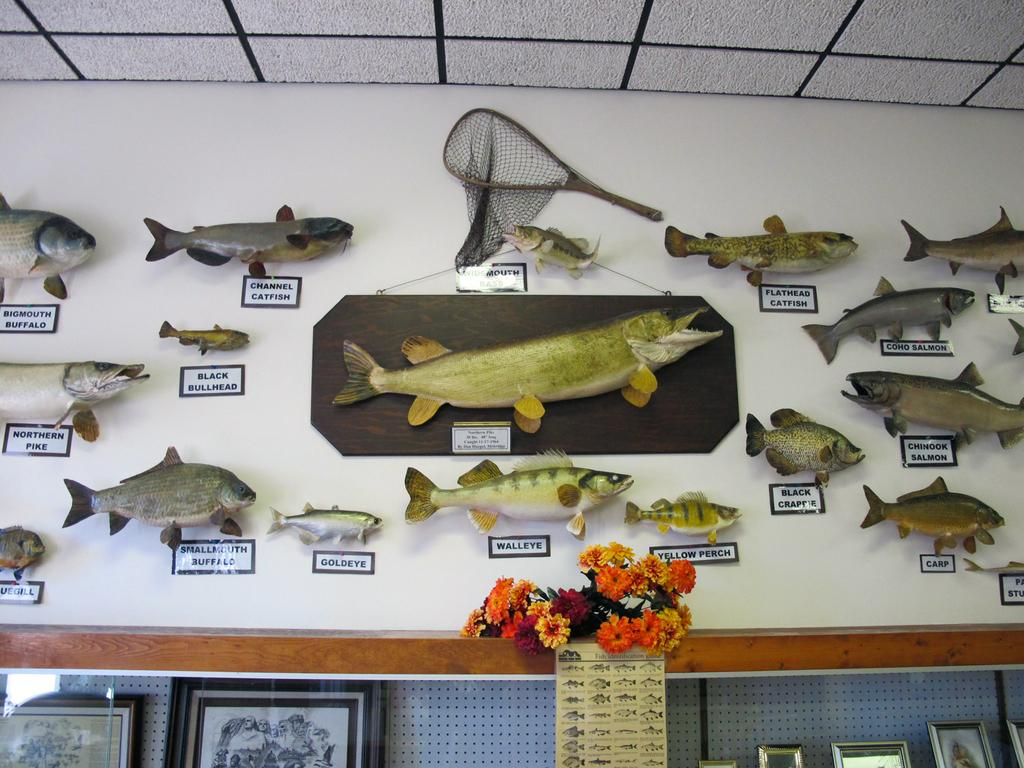What is present on the wall in the image? There are sculptures of fishes and a net, as well as name boards on the wall. What can be found in front of the wall in the image? There are flowers, photo frames, and a photo in front of the wall. Can you describe the sculptures on the wall? The sculptures on the wall are of fishes and a net. What might the name boards on the wall be used for? The name boards on the wall might be used to identify or label different areas or items. What type of stew is being prepared in the image? There is no stew present in the image; it features a wall with sculptures, name boards, and items in front of it. Is there anyone reading a book in the image? There is no indication of anyone reading a book in the image. 